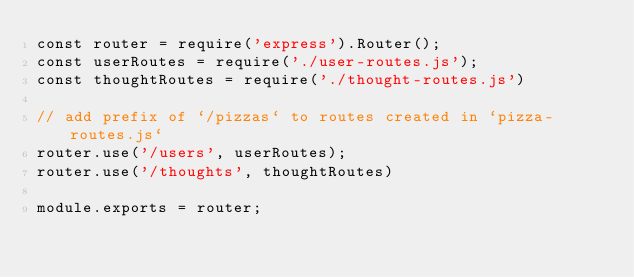<code> <loc_0><loc_0><loc_500><loc_500><_JavaScript_>const router = require('express').Router();
const userRoutes = require('./user-routes.js');
const thoughtRoutes = require('./thought-routes.js')

// add prefix of `/pizzas` to routes created in `pizza-routes.js`
router.use('/users', userRoutes);
router.use('/thoughts', thoughtRoutes)

module.exports = router;</code> 